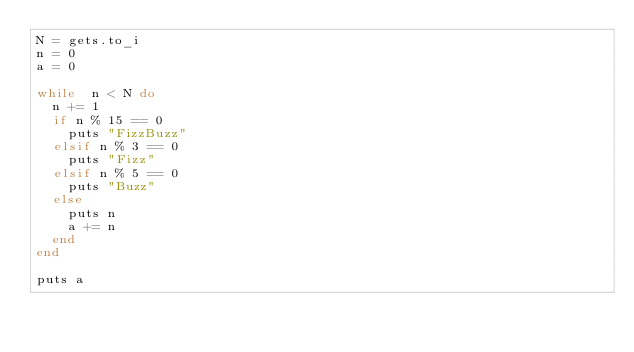Convert code to text. <code><loc_0><loc_0><loc_500><loc_500><_Ruby_>N = gets.to_i
n = 0
a = 0

while  n < N do
  n += 1
  if n % 15 == 0
    puts "FizzBuzz"
  elsif n % 3 == 0
    puts "Fizz"
  elsif n % 5 == 0
    puts "Buzz"
  else
    puts n
    a += n
  end
end

puts a</code> 